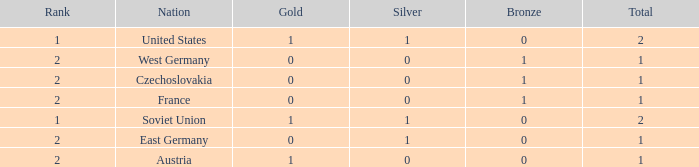What is the total number of bronze medals of West Germany, which is ranked 2 and has less than 1 total medals? 0.0. 